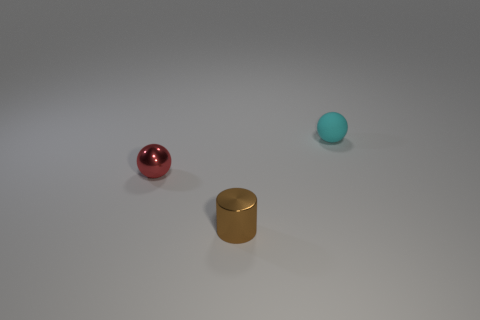Is there anything else that has the same color as the cylinder?
Your answer should be very brief. No. Is there anything else that is made of the same material as the cyan object?
Make the answer very short. No. Are there any other things that have the same shape as the tiny brown metallic object?
Offer a terse response. No. There is a tiny sphere behind the small ball on the left side of the tiny cyan ball; what is its material?
Offer a very short reply. Rubber. What number of cyan rubber objects are the same shape as the red metallic object?
Provide a short and direct response. 1. Is there another small sphere of the same color as the tiny metal ball?
Your response must be concise. No. How many objects are cyan matte objects to the right of the small red ball or spheres behind the red metal ball?
Give a very brief answer. 1. There is a metallic object behind the brown object; are there any cyan things in front of it?
Offer a very short reply. No. There is a cyan object that is the same size as the cylinder; what is its shape?
Offer a very short reply. Sphere. How many things are balls that are on the left side of the small cyan thing or red metallic balls?
Offer a terse response. 1. 